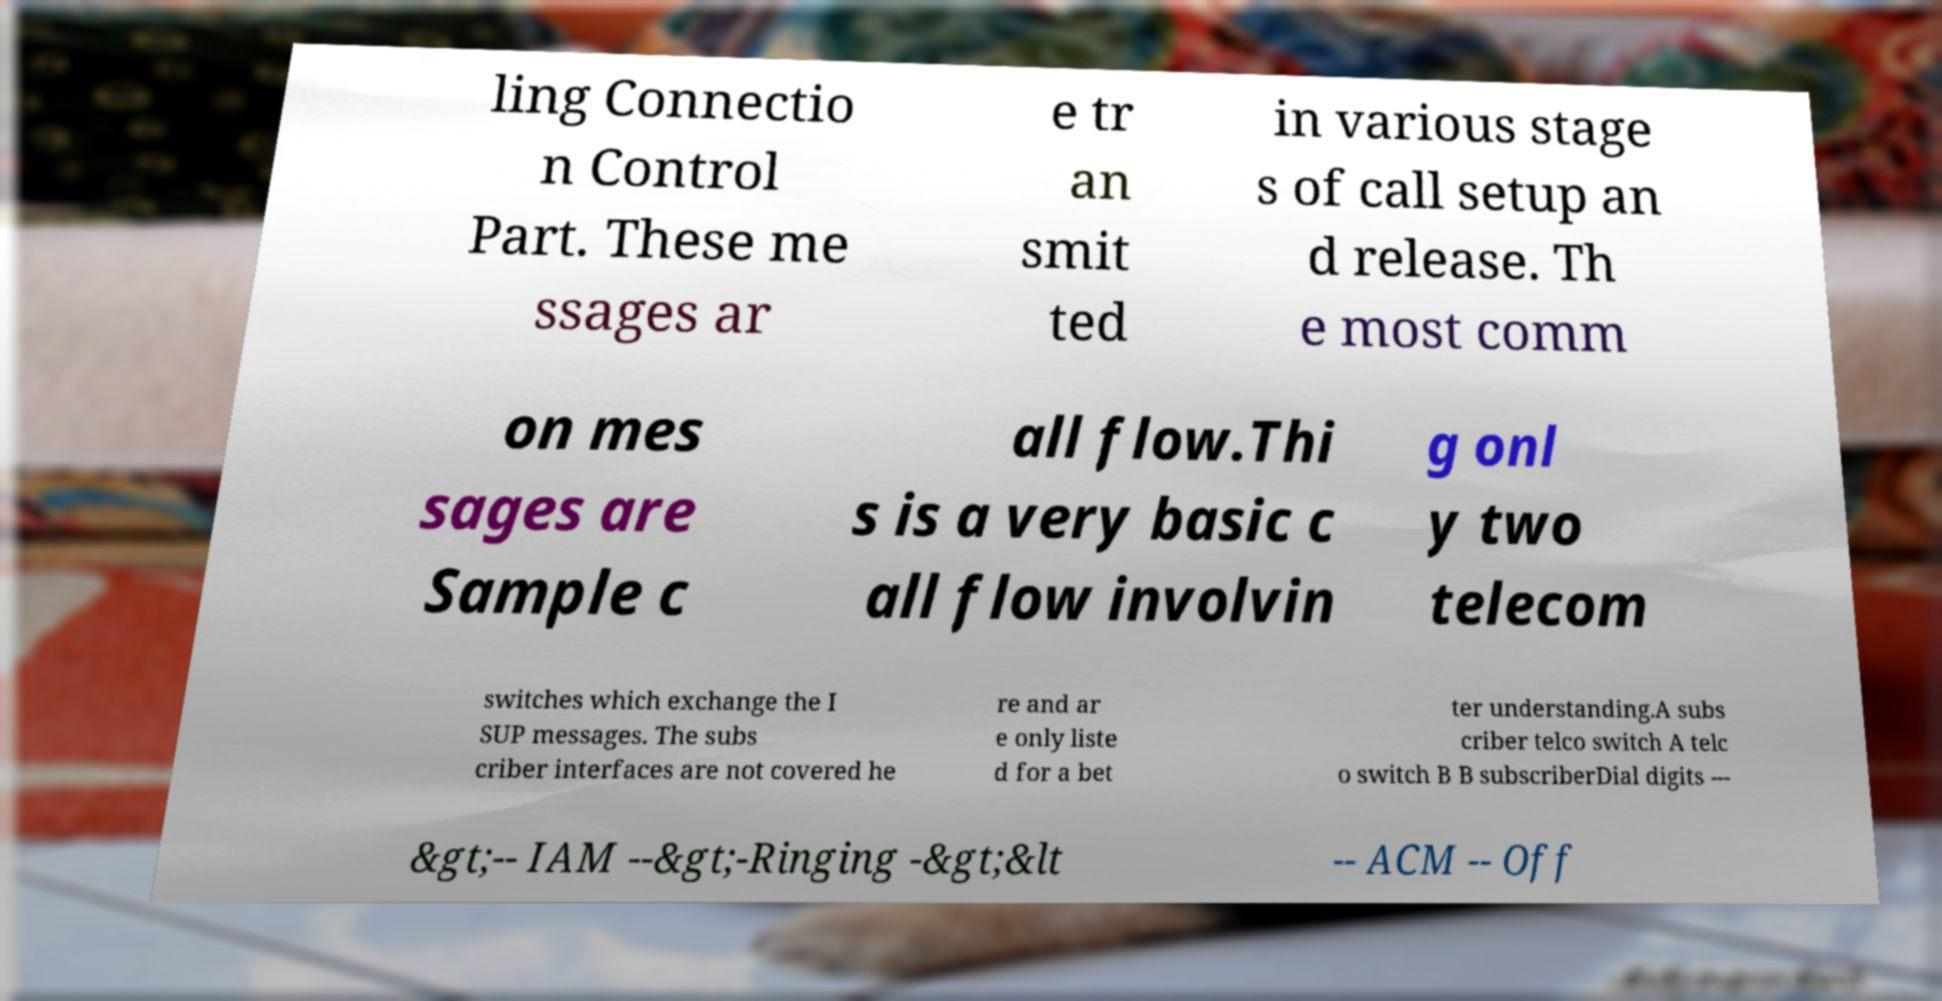I need the written content from this picture converted into text. Can you do that? ling Connectio n Control Part. These me ssages ar e tr an smit ted in various stage s of call setup an d release. Th e most comm on mes sages are Sample c all flow.Thi s is a very basic c all flow involvin g onl y two telecom switches which exchange the I SUP messages. The subs criber interfaces are not covered he re and ar e only liste d for a bet ter understanding.A subs criber telco switch A telc o switch B B subscriberDial digits --- &gt;-- IAM --&gt;-Ringing -&gt;&lt -- ACM -- Off 